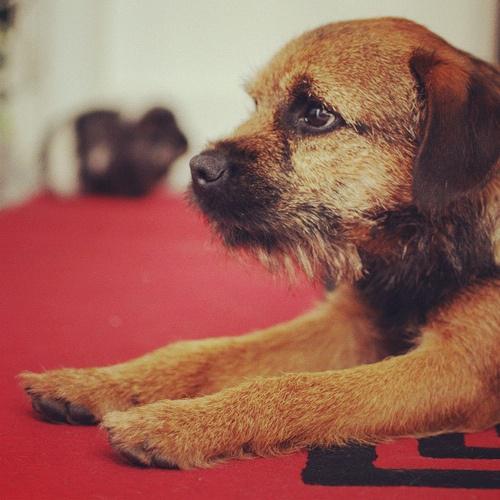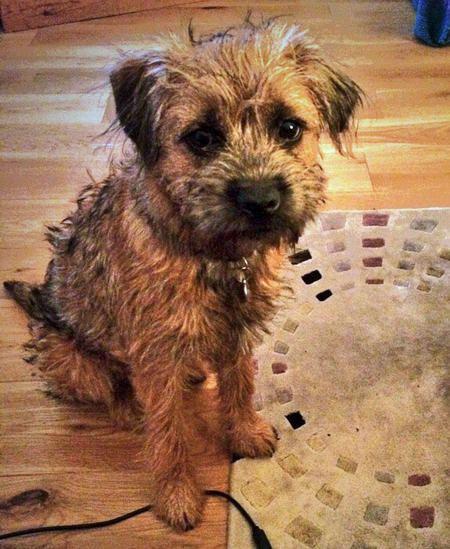The first image is the image on the left, the second image is the image on the right. Evaluate the accuracy of this statement regarding the images: "Atleast one image contains a sleeping or growling dog.". Is it true? Answer yes or no. No. The first image is the image on the left, the second image is the image on the right. Given the left and right images, does the statement "There is a dog sitting upright inside in the right image." hold true? Answer yes or no. Yes. 